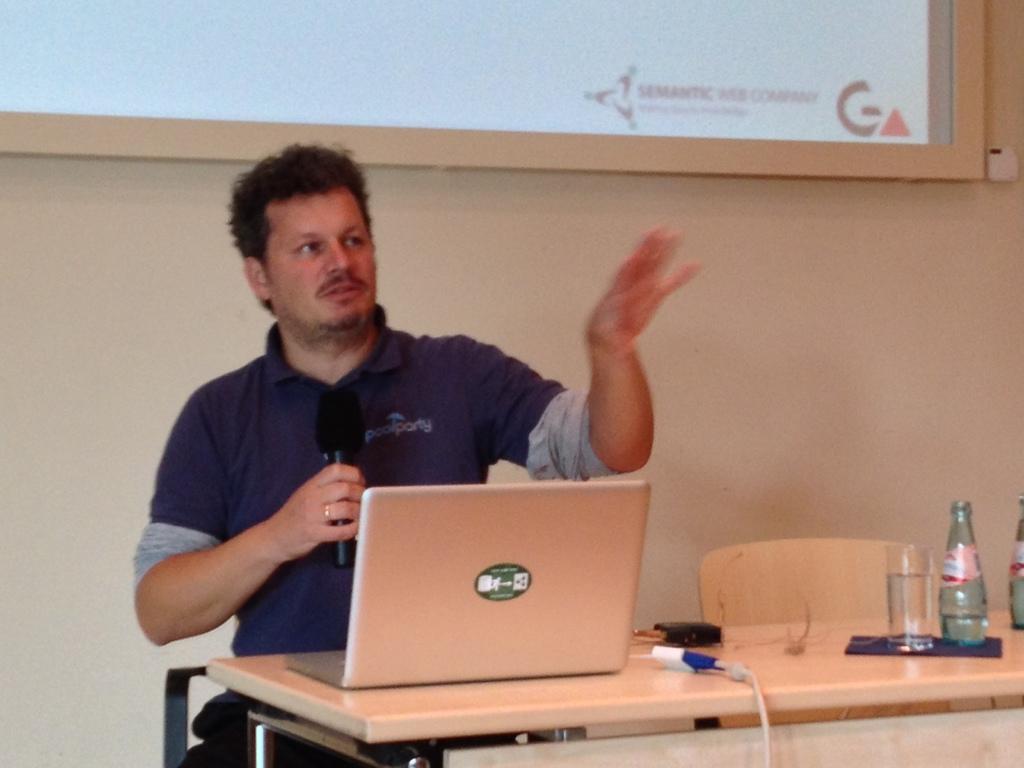What does the logo on the shirt say?
Keep it short and to the point. Poolparty. 